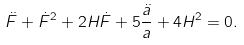<formula> <loc_0><loc_0><loc_500><loc_500>\ddot { F } + \dot { F } ^ { 2 } + 2 H \dot { F } + 5 \frac { \ddot { a } } { a } + 4 H ^ { 2 } = 0 .</formula> 